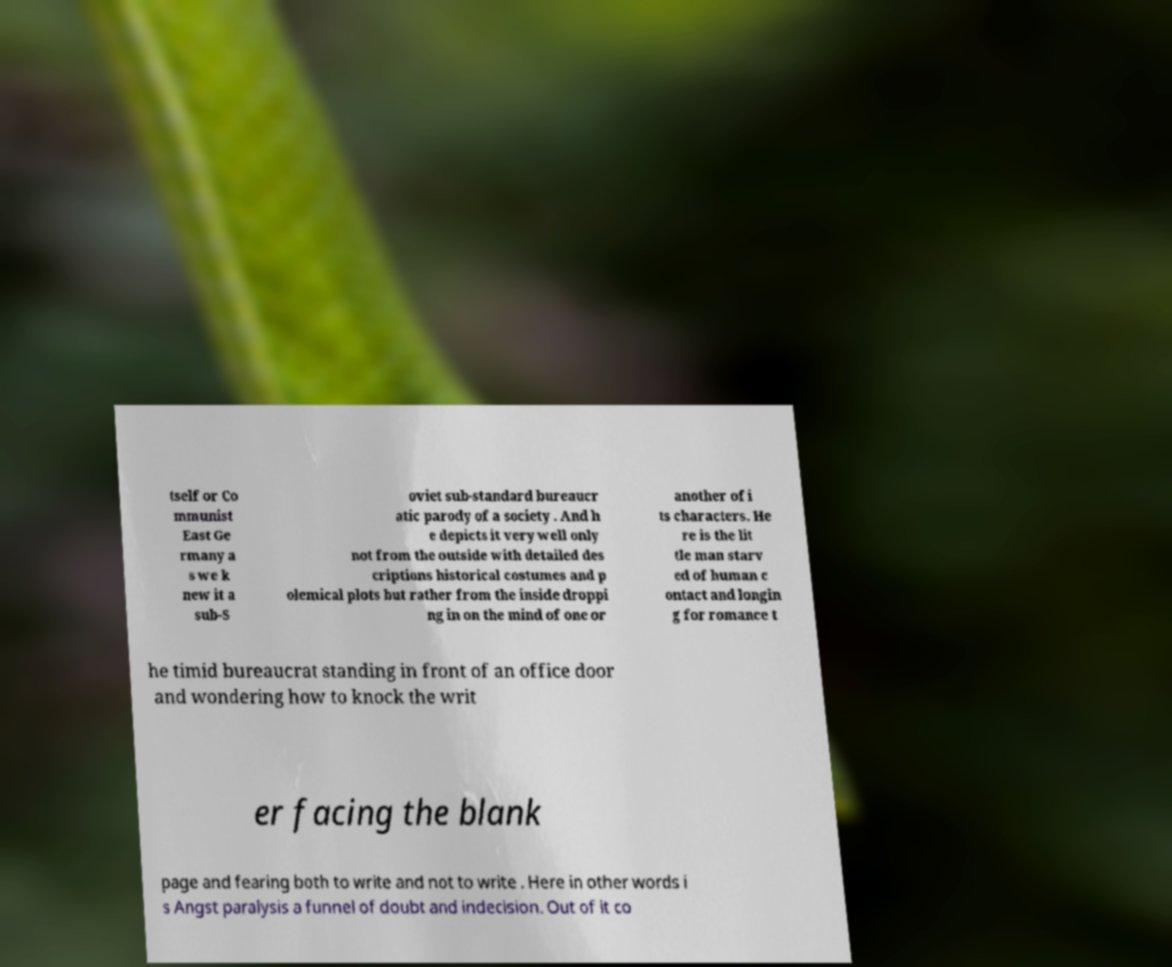Please read and relay the text visible in this image. What does it say? tself or Co mmunist East Ge rmany a s we k new it a sub-S oviet sub-standard bureaucr atic parody of a society . And h e depicts it very well only not from the outside with detailed des criptions historical costumes and p olemical plots but rather from the inside droppi ng in on the mind of one or another of i ts characters. He re is the lit tle man starv ed of human c ontact and longin g for romance t he timid bureaucrat standing in front of an office door and wondering how to knock the writ er facing the blank page and fearing both to write and not to write . Here in other words i s Angst paralysis a funnel of doubt and indecision. Out of it co 